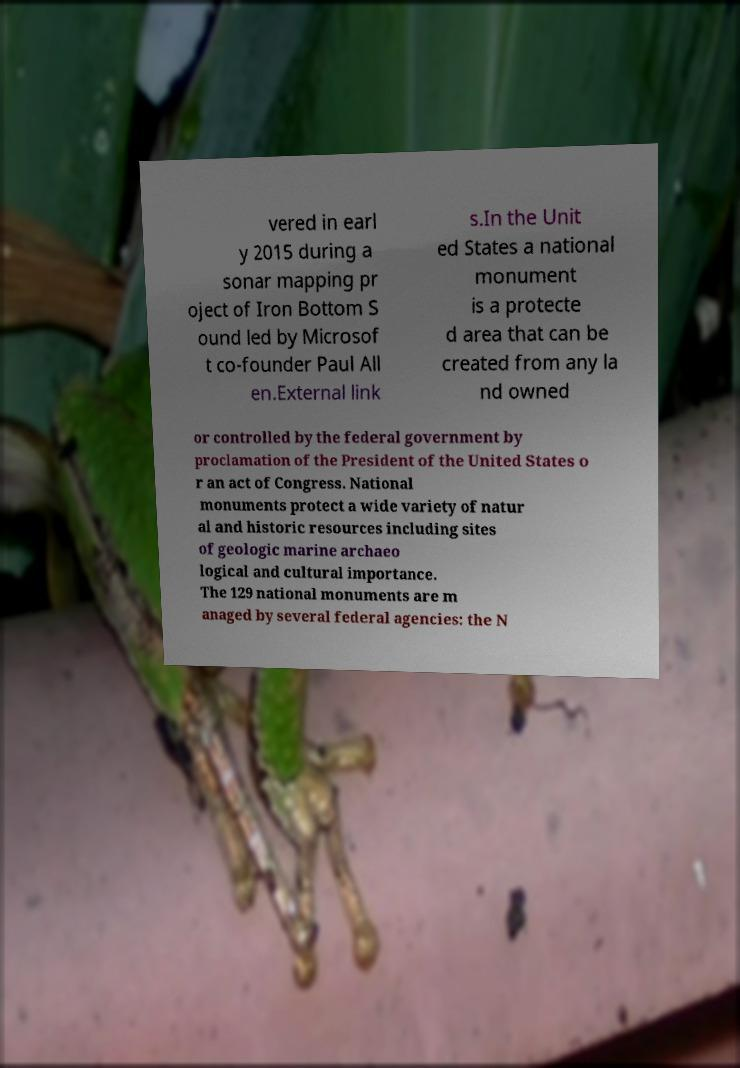Can you accurately transcribe the text from the provided image for me? vered in earl y 2015 during a sonar mapping pr oject of Iron Bottom S ound led by Microsof t co-founder Paul All en.External link s.In the Unit ed States a national monument is a protecte d area that can be created from any la nd owned or controlled by the federal government by proclamation of the President of the United States o r an act of Congress. National monuments protect a wide variety of natur al and historic resources including sites of geologic marine archaeo logical and cultural importance. The 129 national monuments are m anaged by several federal agencies: the N 